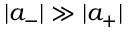Convert formula to latex. <formula><loc_0><loc_0><loc_500><loc_500>| a _ { - } | \gg | a _ { + } |</formula> 